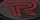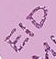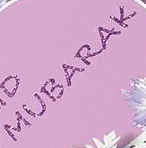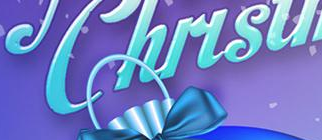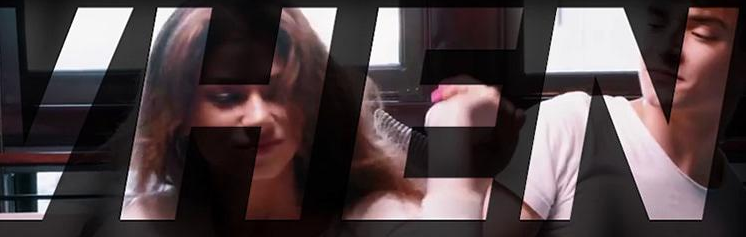What words are shown in these images in order, separated by a semicolon? R; EID; MUBARAK; Chirsu; VHEN 